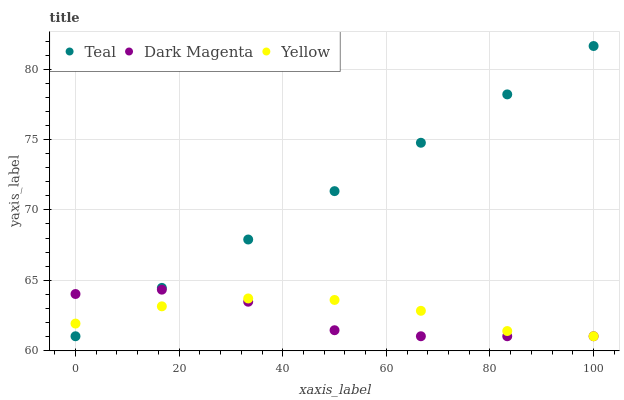Does Dark Magenta have the minimum area under the curve?
Answer yes or no. Yes. Does Teal have the maximum area under the curve?
Answer yes or no. Yes. Does Teal have the minimum area under the curve?
Answer yes or no. No. Does Dark Magenta have the maximum area under the curve?
Answer yes or no. No. Is Teal the smoothest?
Answer yes or no. Yes. Is Dark Magenta the roughest?
Answer yes or no. Yes. Is Dark Magenta the smoothest?
Answer yes or no. No. Is Teal the roughest?
Answer yes or no. No. Does Yellow have the lowest value?
Answer yes or no. Yes. Does Teal have the highest value?
Answer yes or no. Yes. Does Dark Magenta have the highest value?
Answer yes or no. No. Does Teal intersect Dark Magenta?
Answer yes or no. Yes. Is Teal less than Dark Magenta?
Answer yes or no. No. Is Teal greater than Dark Magenta?
Answer yes or no. No. 